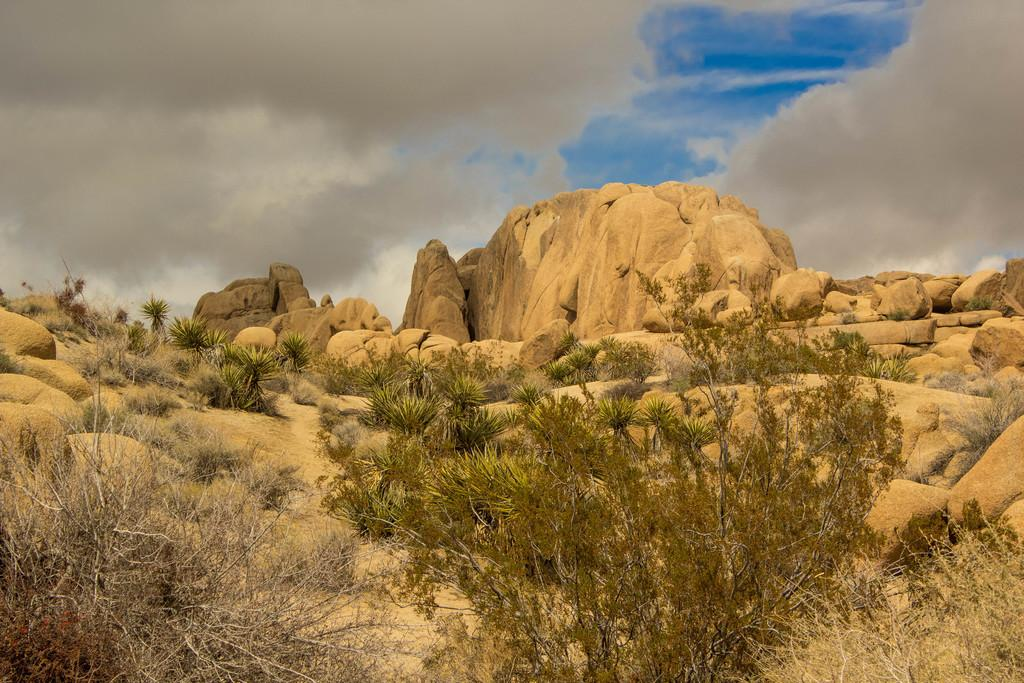What type of plant is visible in the image? There is a plant in the image, and it is green in color. What can be seen on either side of the plant? There are dried trees on either side of the plant. What other objects are present in the image? There are rocks and plants in front of the main plant. How would you describe the sky in the image? The sky is cloudy in the image. Can you tell me what type of locket is hanging from the plant in the image? There is no locket present in the image; it features a green plant with dried trees on either side and rocks in the foreground. What flavor of pie is being served at the airport in the image? There is no airport or pie present in the image; it is a scene with a green plant, dried trees, and rocks. 